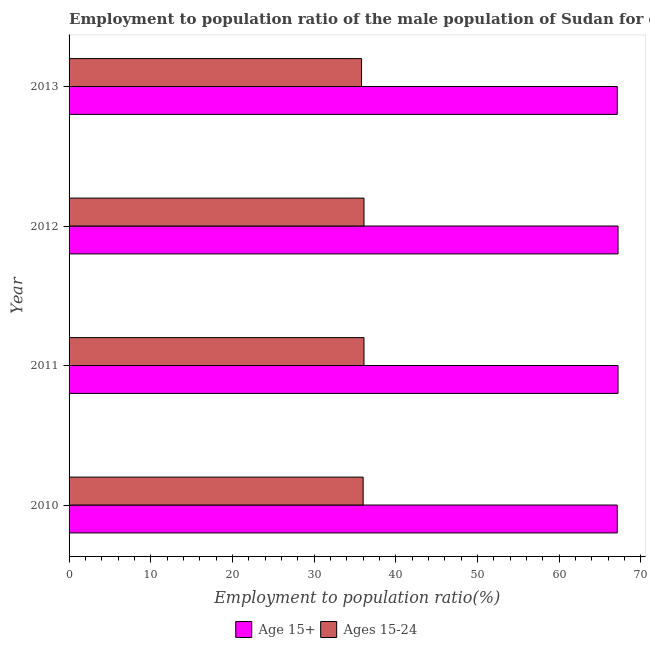How many different coloured bars are there?
Your response must be concise. 2. How many groups of bars are there?
Offer a very short reply. 4. In how many cases, is the number of bars for a given year not equal to the number of legend labels?
Provide a succinct answer. 0. What is the employment to population ratio(age 15-24) in 2011?
Keep it short and to the point. 36.1. Across all years, what is the maximum employment to population ratio(age 15-24)?
Your answer should be compact. 36.1. Across all years, what is the minimum employment to population ratio(age 15-24)?
Keep it short and to the point. 35.8. What is the total employment to population ratio(age 15+) in the graph?
Your response must be concise. 268.6. What is the difference between the employment to population ratio(age 15-24) in 2010 and the employment to population ratio(age 15+) in 2011?
Provide a short and direct response. -31.2. What is the average employment to population ratio(age 15+) per year?
Your answer should be compact. 67.15. In the year 2013, what is the difference between the employment to population ratio(age 15-24) and employment to population ratio(age 15+)?
Provide a short and direct response. -31.3. In how many years, is the employment to population ratio(age 15-24) greater than 16 %?
Your response must be concise. 4. Is the employment to population ratio(age 15+) in 2011 less than that in 2012?
Your answer should be very brief. No. What is the difference between the highest and the lowest employment to population ratio(age 15-24)?
Your answer should be compact. 0.3. Is the sum of the employment to population ratio(age 15+) in 2010 and 2011 greater than the maximum employment to population ratio(age 15-24) across all years?
Keep it short and to the point. Yes. What does the 2nd bar from the top in 2010 represents?
Provide a short and direct response. Age 15+. What does the 2nd bar from the bottom in 2013 represents?
Your response must be concise. Ages 15-24. How many years are there in the graph?
Your answer should be very brief. 4. What is the difference between two consecutive major ticks on the X-axis?
Offer a very short reply. 10. Are the values on the major ticks of X-axis written in scientific E-notation?
Provide a short and direct response. No. Does the graph contain any zero values?
Offer a very short reply. No. How are the legend labels stacked?
Give a very brief answer. Horizontal. What is the title of the graph?
Your response must be concise. Employment to population ratio of the male population of Sudan for different age-groups. Does "From production" appear as one of the legend labels in the graph?
Your response must be concise. No. What is the label or title of the X-axis?
Keep it short and to the point. Employment to population ratio(%). What is the label or title of the Y-axis?
Give a very brief answer. Year. What is the Employment to population ratio(%) in Age 15+ in 2010?
Your response must be concise. 67.1. What is the Employment to population ratio(%) in Ages 15-24 in 2010?
Your answer should be very brief. 36. What is the Employment to population ratio(%) of Age 15+ in 2011?
Give a very brief answer. 67.2. What is the Employment to population ratio(%) of Ages 15-24 in 2011?
Provide a succinct answer. 36.1. What is the Employment to population ratio(%) of Age 15+ in 2012?
Your answer should be very brief. 67.2. What is the Employment to population ratio(%) of Ages 15-24 in 2012?
Your response must be concise. 36.1. What is the Employment to population ratio(%) of Age 15+ in 2013?
Provide a short and direct response. 67.1. What is the Employment to population ratio(%) of Ages 15-24 in 2013?
Keep it short and to the point. 35.8. Across all years, what is the maximum Employment to population ratio(%) of Age 15+?
Provide a succinct answer. 67.2. Across all years, what is the maximum Employment to population ratio(%) of Ages 15-24?
Your answer should be very brief. 36.1. Across all years, what is the minimum Employment to population ratio(%) of Age 15+?
Offer a terse response. 67.1. Across all years, what is the minimum Employment to population ratio(%) in Ages 15-24?
Your response must be concise. 35.8. What is the total Employment to population ratio(%) in Age 15+ in the graph?
Provide a short and direct response. 268.6. What is the total Employment to population ratio(%) of Ages 15-24 in the graph?
Your response must be concise. 144. What is the difference between the Employment to population ratio(%) in Age 15+ in 2010 and that in 2011?
Provide a succinct answer. -0.1. What is the difference between the Employment to population ratio(%) of Ages 15-24 in 2010 and that in 2011?
Your answer should be compact. -0.1. What is the difference between the Employment to population ratio(%) in Ages 15-24 in 2010 and that in 2012?
Offer a very short reply. -0.1. What is the difference between the Employment to population ratio(%) of Ages 15-24 in 2010 and that in 2013?
Your answer should be compact. 0.2. What is the difference between the Employment to population ratio(%) of Age 15+ in 2011 and that in 2012?
Your response must be concise. 0. What is the difference between the Employment to population ratio(%) of Ages 15-24 in 2011 and that in 2012?
Your answer should be very brief. 0. What is the difference between the Employment to population ratio(%) of Age 15+ in 2011 and that in 2013?
Your response must be concise. 0.1. What is the difference between the Employment to population ratio(%) in Ages 15-24 in 2011 and that in 2013?
Your answer should be compact. 0.3. What is the difference between the Employment to population ratio(%) of Age 15+ in 2010 and the Employment to population ratio(%) of Ages 15-24 in 2011?
Provide a succinct answer. 31. What is the difference between the Employment to population ratio(%) of Age 15+ in 2010 and the Employment to population ratio(%) of Ages 15-24 in 2012?
Your answer should be compact. 31. What is the difference between the Employment to population ratio(%) in Age 15+ in 2010 and the Employment to population ratio(%) in Ages 15-24 in 2013?
Ensure brevity in your answer.  31.3. What is the difference between the Employment to population ratio(%) of Age 15+ in 2011 and the Employment to population ratio(%) of Ages 15-24 in 2012?
Give a very brief answer. 31.1. What is the difference between the Employment to population ratio(%) of Age 15+ in 2011 and the Employment to population ratio(%) of Ages 15-24 in 2013?
Provide a short and direct response. 31.4. What is the difference between the Employment to population ratio(%) of Age 15+ in 2012 and the Employment to population ratio(%) of Ages 15-24 in 2013?
Provide a short and direct response. 31.4. What is the average Employment to population ratio(%) of Age 15+ per year?
Make the answer very short. 67.15. What is the average Employment to population ratio(%) in Ages 15-24 per year?
Your answer should be very brief. 36. In the year 2010, what is the difference between the Employment to population ratio(%) in Age 15+ and Employment to population ratio(%) in Ages 15-24?
Your answer should be very brief. 31.1. In the year 2011, what is the difference between the Employment to population ratio(%) of Age 15+ and Employment to population ratio(%) of Ages 15-24?
Keep it short and to the point. 31.1. In the year 2012, what is the difference between the Employment to population ratio(%) of Age 15+ and Employment to population ratio(%) of Ages 15-24?
Offer a very short reply. 31.1. In the year 2013, what is the difference between the Employment to population ratio(%) in Age 15+ and Employment to population ratio(%) in Ages 15-24?
Your response must be concise. 31.3. What is the ratio of the Employment to population ratio(%) in Age 15+ in 2010 to that in 2012?
Offer a terse response. 1. What is the ratio of the Employment to population ratio(%) of Ages 15-24 in 2010 to that in 2012?
Give a very brief answer. 1. What is the ratio of the Employment to population ratio(%) of Ages 15-24 in 2010 to that in 2013?
Your answer should be very brief. 1.01. What is the ratio of the Employment to population ratio(%) in Age 15+ in 2011 to that in 2012?
Make the answer very short. 1. What is the ratio of the Employment to population ratio(%) in Ages 15-24 in 2011 to that in 2012?
Provide a short and direct response. 1. What is the ratio of the Employment to population ratio(%) of Age 15+ in 2011 to that in 2013?
Ensure brevity in your answer.  1. What is the ratio of the Employment to population ratio(%) in Ages 15-24 in 2011 to that in 2013?
Offer a terse response. 1.01. What is the ratio of the Employment to population ratio(%) in Age 15+ in 2012 to that in 2013?
Offer a terse response. 1. What is the ratio of the Employment to population ratio(%) of Ages 15-24 in 2012 to that in 2013?
Your answer should be very brief. 1.01. What is the difference between the highest and the lowest Employment to population ratio(%) in Ages 15-24?
Your answer should be very brief. 0.3. 